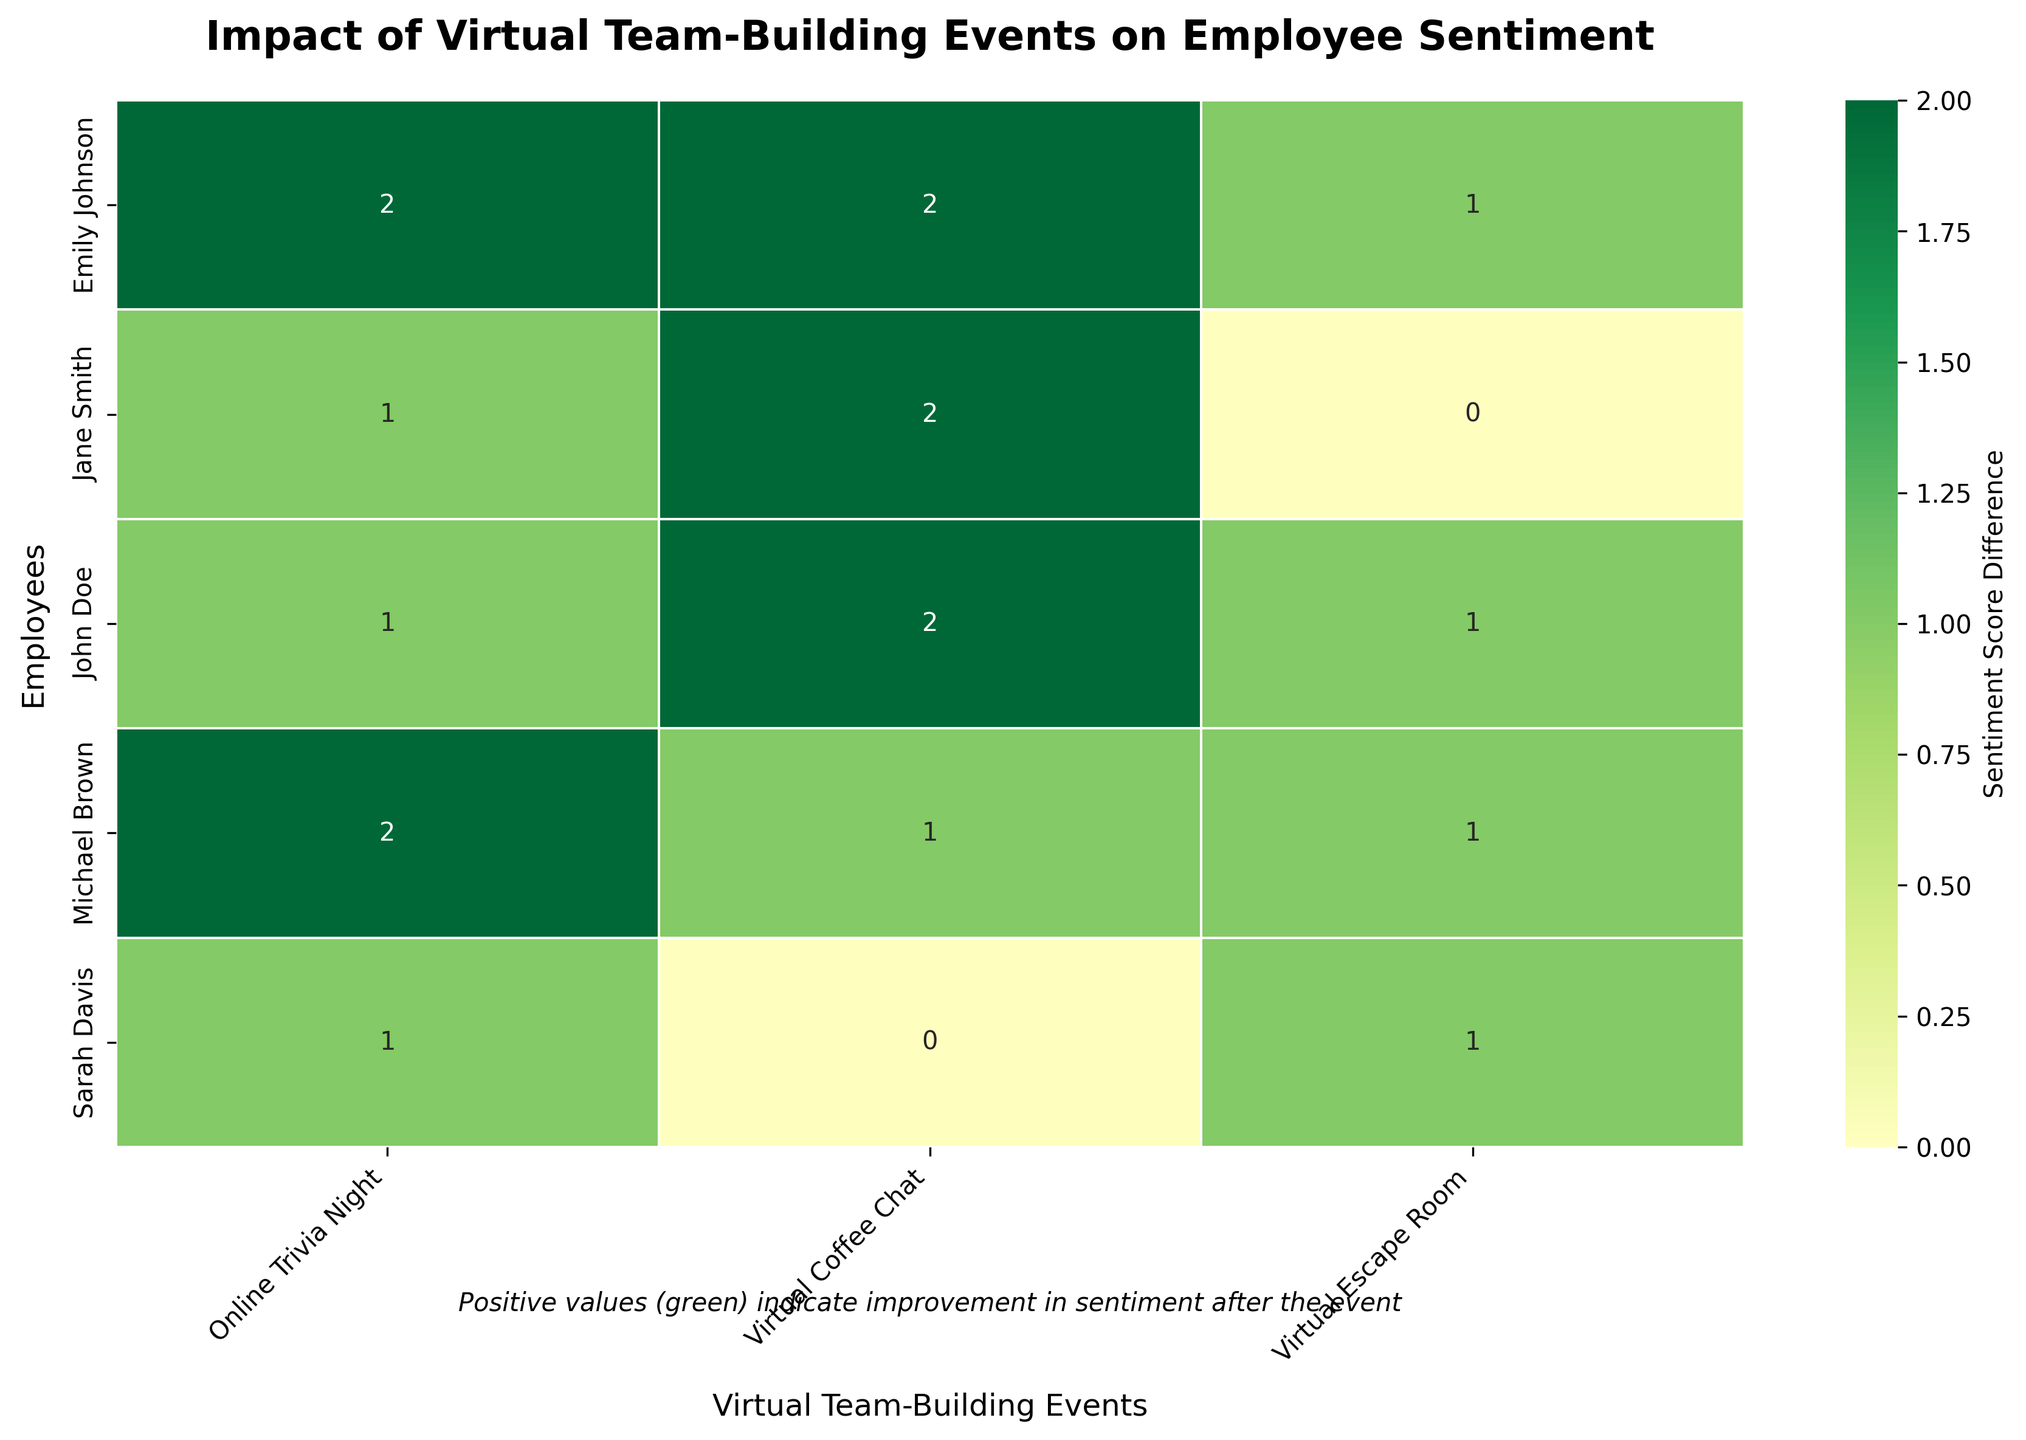What is the title of the heatmap? The title of the heatmap is written at the top center and reads "Impact of Virtual Team-Building Events on Employee Sentiment".
Answer: Impact of Virtual Team-Building Events on Employee Sentiment Which virtual team-building event had the highest average improvement in employee sentiment? To find the highest average improvement, compute the average difference in sentiment scores for each event. Sum the differences for each event and divide by the number of employees. Visually compare these averages: Virtual Coffee Chat (2), Online Trivia Night (1.4), Virtual Escape Room (0.8).
Answer: Virtual Coffee Chat How many employees showed a positive change in sentiment after the "Online Trivia Night"? Count the number of employees with positive sentiment differences in the "Online Trivia Night" column. The values are 1, 1, 2, 2, 1. There are 5 employees in total with positive differences.
Answer: 5 Which employee had the greatest increase in sentiment after the "Virtual Coffee Chat"? Compare the sentiment differences for each employee under the "Virtual Coffee Chat" column. The highest value is 2, shown by John Doe (2) and Emily Johnson (2).
Answer: John Doe, Emily Johnson Did any employee's sentiment remain unchanged after any event? Look for any cells with a value of 0. From the heatmap, Sarah Davis has a 0 change in the "Virtual Coffee Chat" and Jane Smith has a 0 change in the "Virtual Escape Room".
Answer: Yes What is the sentiment score difference for Michael Brown after the "Virtual Escape Room" event? Locate Michael Brown in the "Virtual Escape Room" column and note the value. The difference in sentiment score for Michael Brown is 1.
Answer: 1 What is the average sentiment score improvement for all employees after participating in the "Virtual Coffee Chat"? Sum the sentiment differences (+2, +2, +2, +1, 0) for all employees in the "Virtual Coffee Chat" and divide by the number of employees, 5. The sum is 7, so 7 / 5 = 1.4.
Answer: 1.4 Which virtual team-building event generally had the least impact on employee sentiment? Look for the event with the lowest sentiment differences both in terms of the number of employees and average score change. Virtual Escape Room has relatively lower and consistent marginal differences (0.8).
Answer: Virtual Escape Room Are there any employees who showed a consistent increase in sentiment across all events? Check each employee's sentiment difference for all events and verify if they are positive. Jane Smith (2, 1) and John Doe (2, 1, 1) showed consistent increases across all events.
Answer: Yes, Jane Smith and John Doe What is the overall sentiment score change for Sarah Davis across all events? Sum all of Sarah Davis's sentiment differences across events: 0 (Virtual Coffee Chat) + 1 (Online Trivia Night) + 1 (Virtual Escape Room) = 2
Answer: 2 